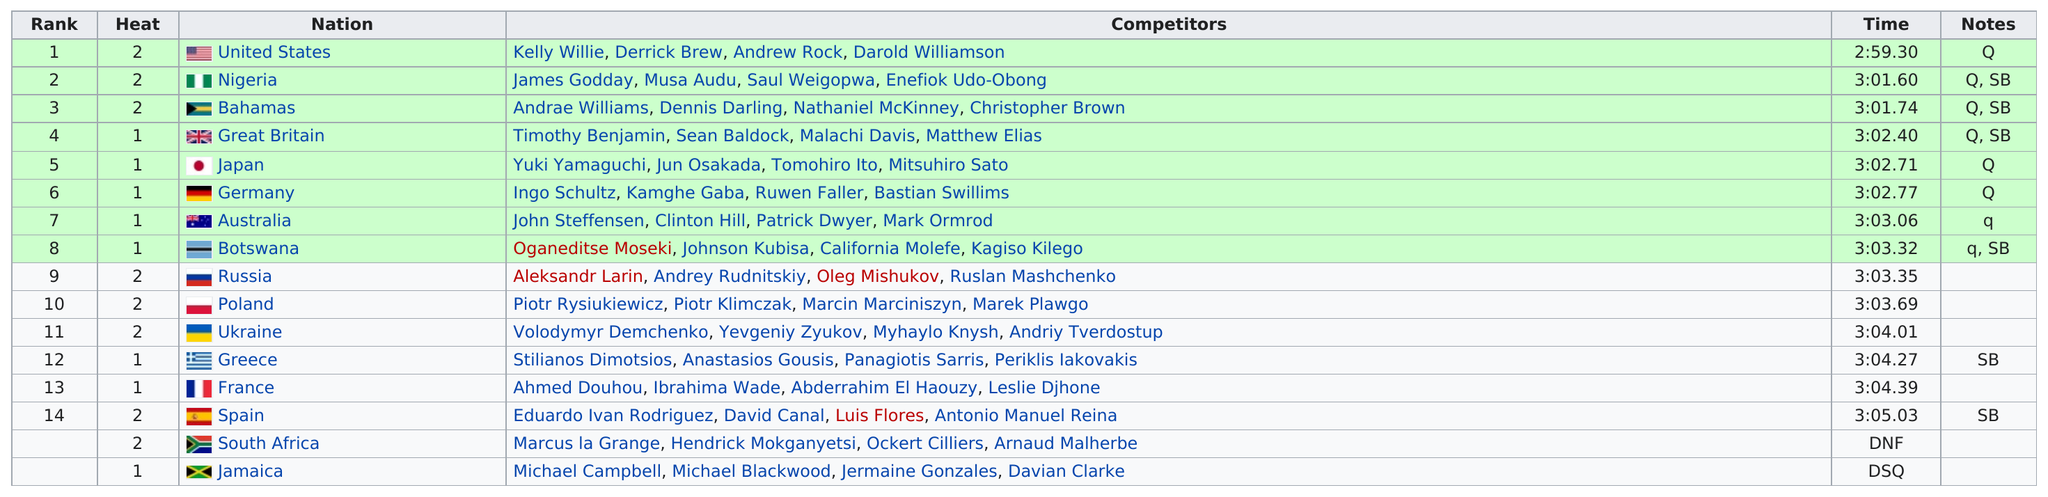Outline some significant characteristics in this image. Spain came in last, excluding disqualified and incomplete teams. At least three teams were able to qualify and participate in the event within the time limit of 3 hours. The United States took the least amount of time. The total time for France was 3:04.39. France was the nation that existed prior to Spain. 